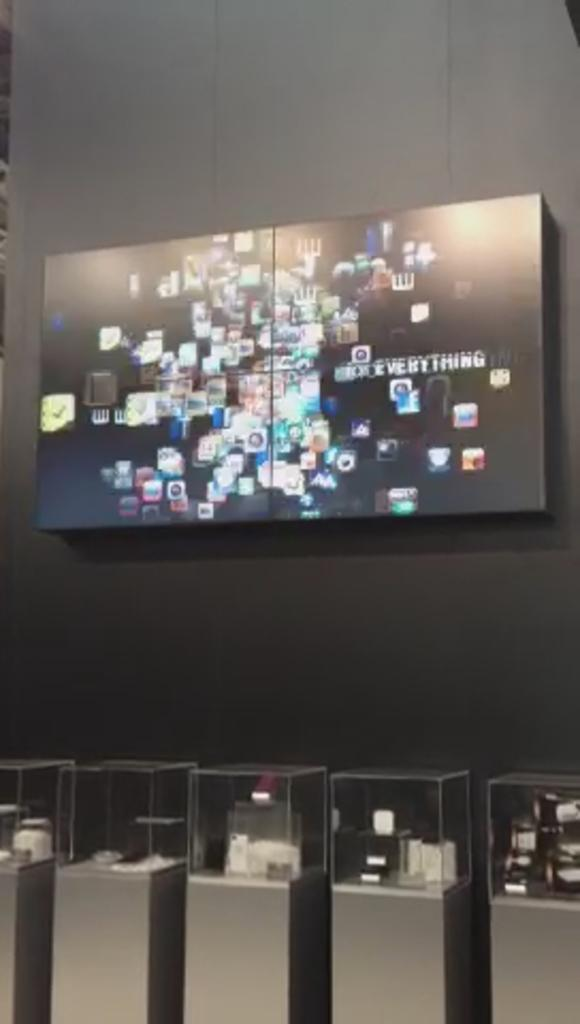<image>
Write a terse but informative summary of the picture. A large box on the wall with several pictures and the phrase "everything" written on it. 